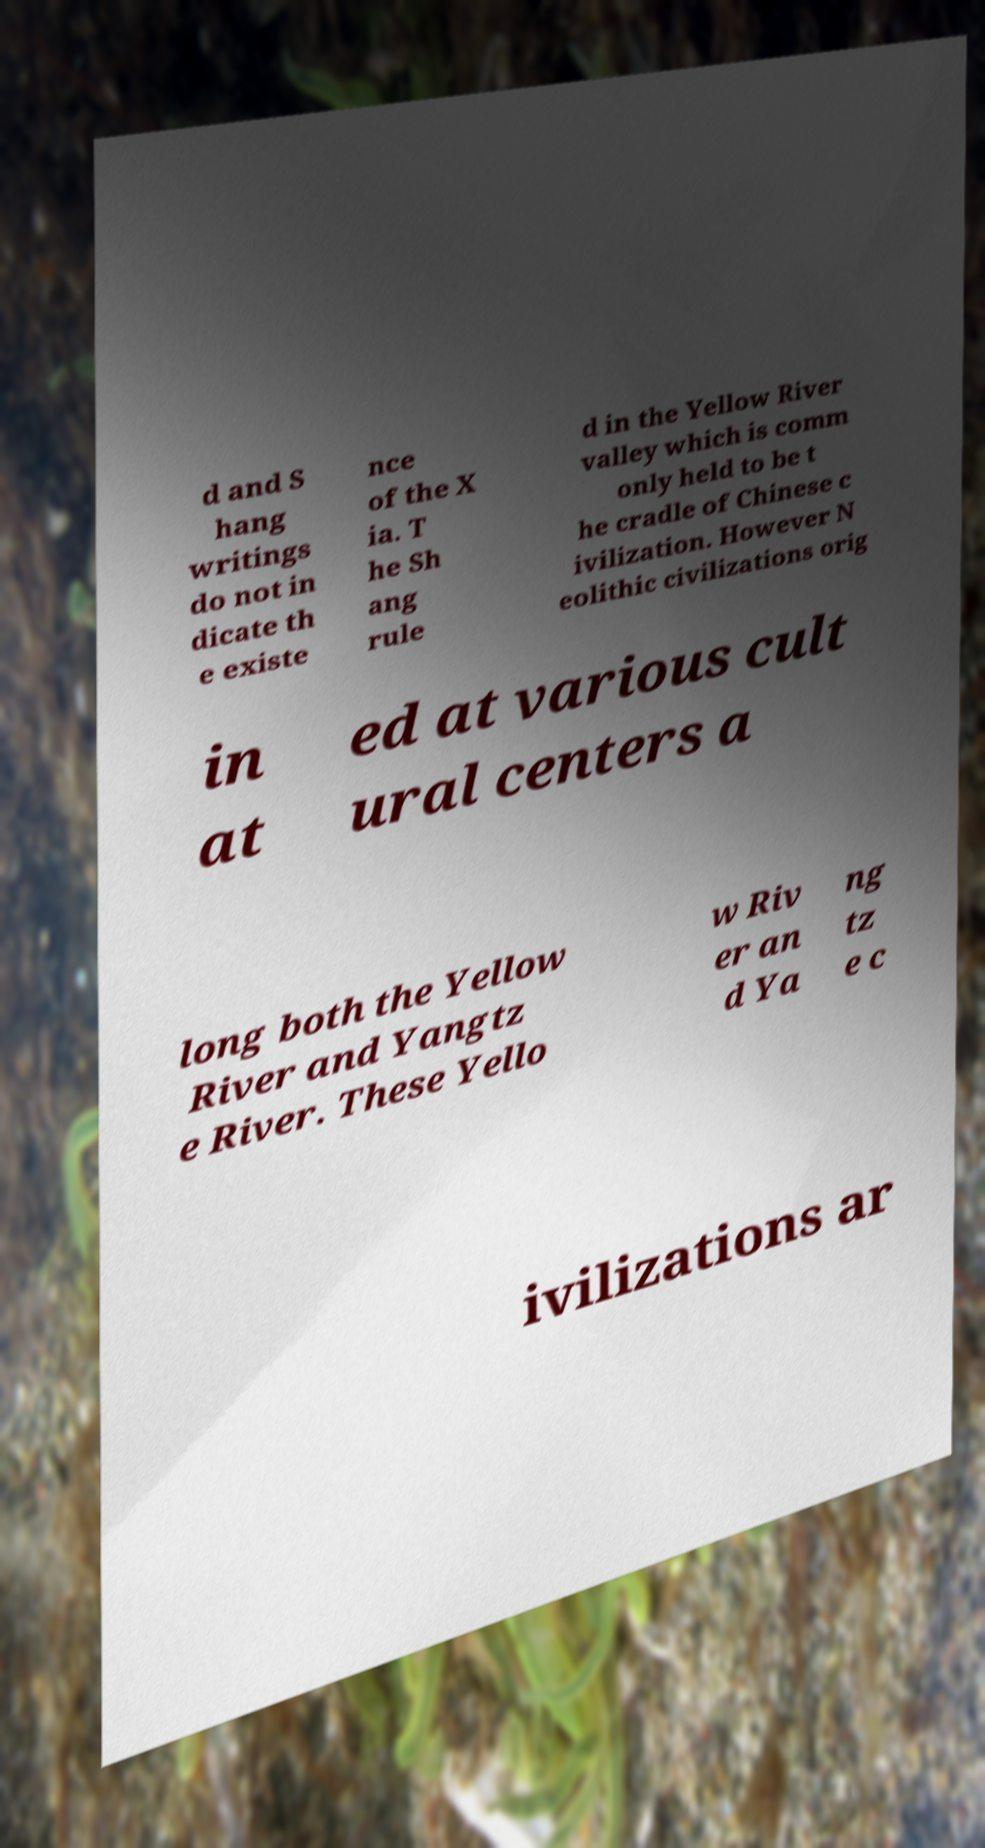Could you assist in decoding the text presented in this image and type it out clearly? d and S hang writings do not in dicate th e existe nce of the X ia. T he Sh ang rule d in the Yellow River valley which is comm only held to be t he cradle of Chinese c ivilization. However N eolithic civilizations orig in at ed at various cult ural centers a long both the Yellow River and Yangtz e River. These Yello w Riv er an d Ya ng tz e c ivilizations ar 